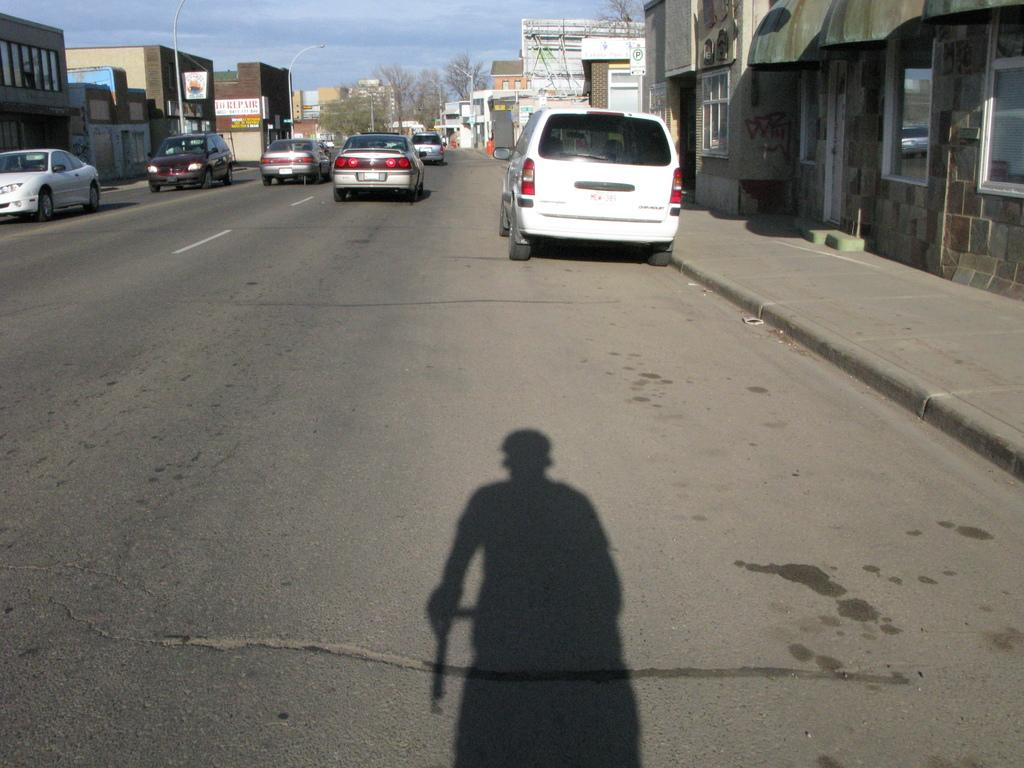What is happening on the road in the image? There are vehicles on the road in the image. What can be seen in the background of the image? There are street lights, trees, and buildings in the background of the image. Can you describe any additional details about the image? A shadow of a person is visible in the image. What type of salt is being used to season the vehicles in the image? There is no salt present in the image, and the vehicles are not being seasoned. 